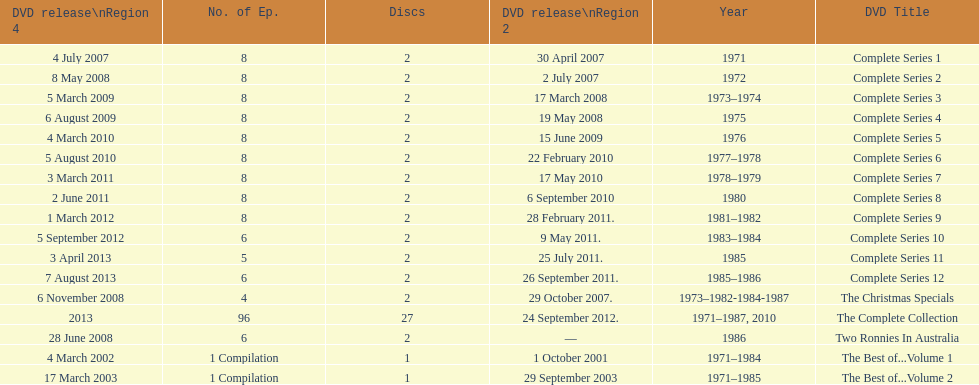How many "best of" volumes compile the top episodes of the television show "the two ronnies". 2. 